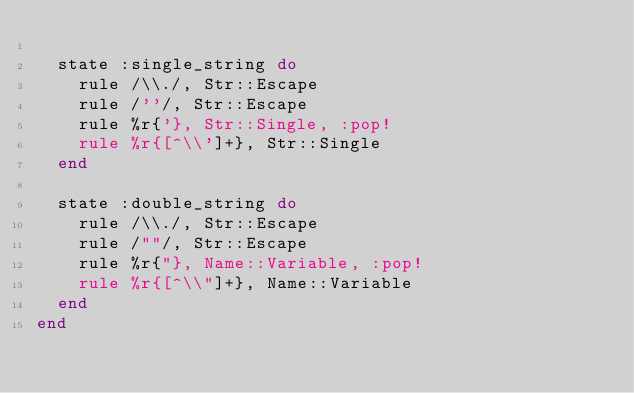Convert code to text. <code><loc_0><loc_0><loc_500><loc_500><_Ruby_>
  state :single_string do
    rule /\\./, Str::Escape
    rule /''/, Str::Escape
    rule %r{'}, Str::Single, :pop!
    rule %r{[^\\']+}, Str::Single
  end

  state :double_string do
    rule /\\./, Str::Escape
    rule /""/, Str::Escape
    rule %r{"}, Name::Variable, :pop!
    rule %r{[^\\"]+}, Name::Variable
  end
end
</code> 